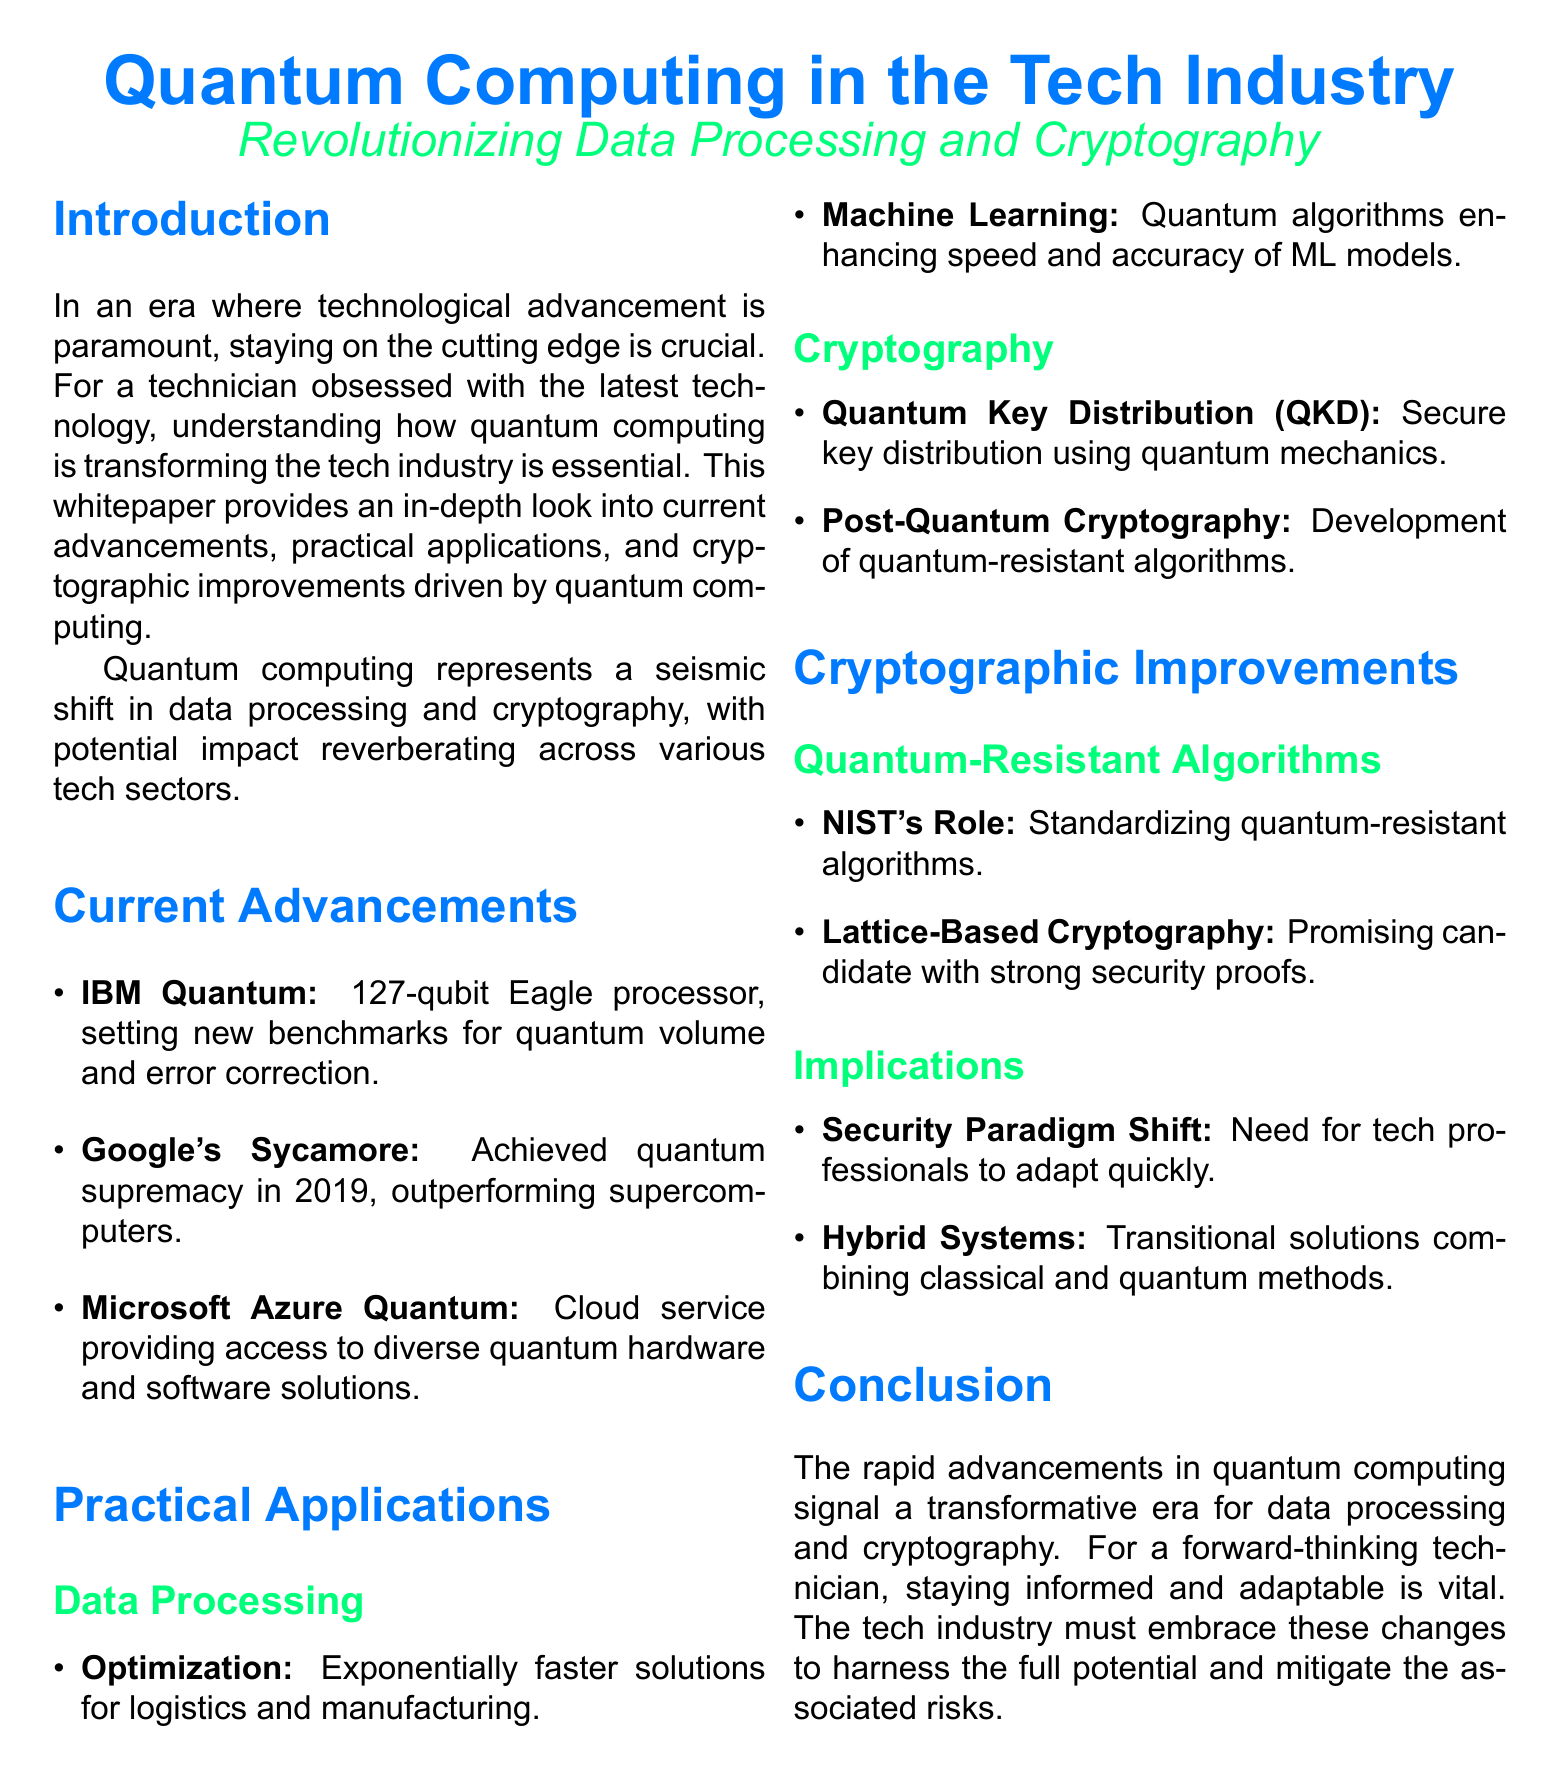What is the qubit count of IBM's Eagle processor? The document states that IBM's Eagle processor has a qubit count of 127.
Answer: 127 Which company achieved quantum supremacy in 2019? According to the document, Google achieved quantum supremacy in 2019 with its Sycamore processor.
Answer: Google What is a practical application of quantum computing in logistics? The document mentions optimization as a practical application of quantum computing in logistics and manufacturing.
Answer: Optimization What does QKD stand for in the context of quantum cryptography? The document refers to QKD as Quantum Key Distribution in relation to secure key distribution.
Answer: Quantum Key Distribution What role does NIST play in quantum-resistant algorithms? The document explains that NIST is responsible for standardizing quantum-resistant algorithms.
Answer: Standardizing How does quantum computing impact security paradigms? The document asserts there is a security paradigm shift requiring quick adaptation from tech professionals.
Answer: Security paradigm shift What is a promising candidate for quantum-resistant algorithms mentioned in the document? The document states that lattice-based cryptography is a promising candidate with strong security proofs.
Answer: Lattice-Based Cryptography Which tech service provides access to diverse quantum hardware? The document notes that Microsoft Azure Quantum is a cloud service providing access to diverse quantum hardware and software solutions.
Answer: Microsoft Azure Quantum What are hybrid systems in the context of quantum computing? The document describes hybrid systems as transitional solutions that combine classical and quantum methods.
Answer: Transitional solutions 